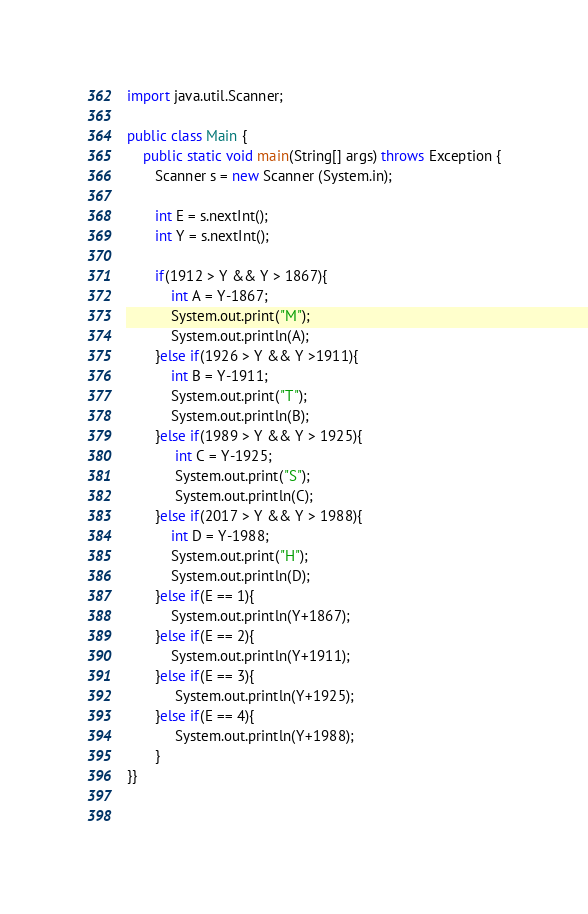<code> <loc_0><loc_0><loc_500><loc_500><_Java_>import java.util.Scanner;

public class Main {
    public static void main(String[] args) throws Exception {
       Scanner s = new Scanner (System.in);
       
       int E = s.nextInt();
       int Y = s.nextInt();
       
       if(1912 > Y && Y > 1867){
           int A = Y-1867;
           System.out.print("M");
           System.out.println(A);
       }else if(1926 > Y && Y >1911){
           int B = Y-1911;
           System.out.print("T");
           System.out.println(B);
       }else if(1989 > Y && Y > 1925){
            int C = Y-1925;
            System.out.print("S");
            System.out.println(C);
       }else if(2017 > Y && Y > 1988){
           int D = Y-1988;
           System.out.print("H");
           System.out.println(D);
       }else if(E == 1){
           System.out.println(Y+1867);
       }else if(E == 2){
           System.out.println(Y+1911);
       }else if(E == 3){
            System.out.println(Y+1925);
       }else if(E == 4){
            System.out.println(Y+1988);
       }
}}
       
       </code> 